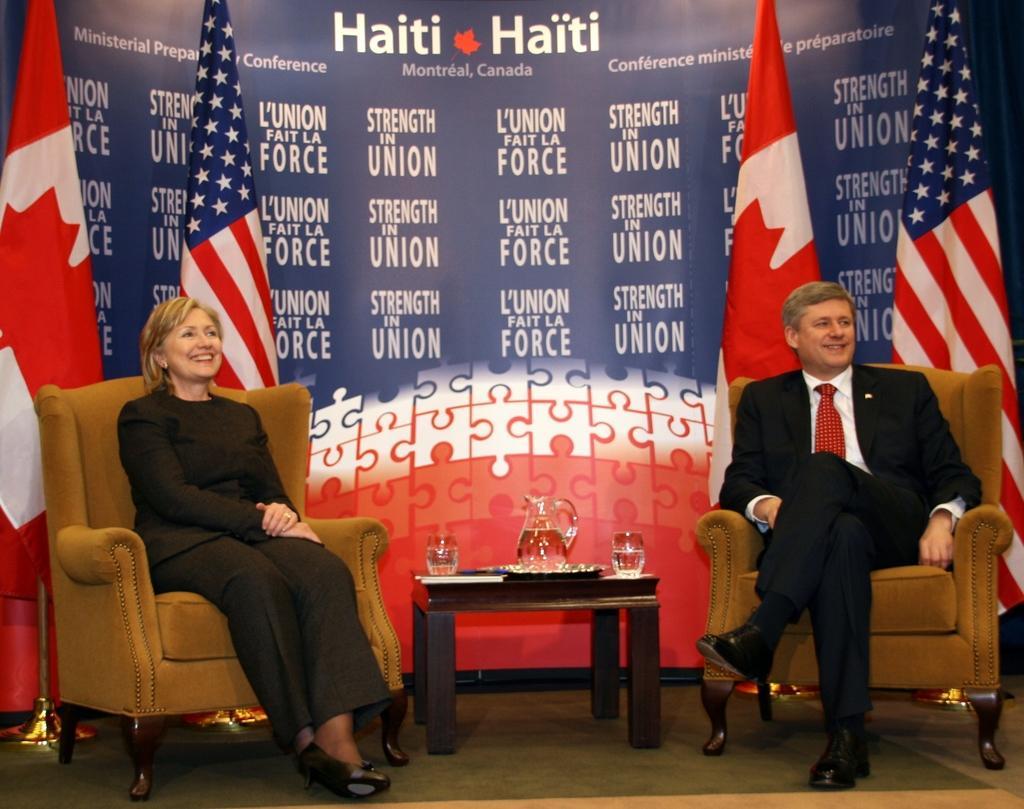Can you describe this image briefly? In the image there is a man and woman sat on chair in front there is a table with water jug and in background there are flags. 